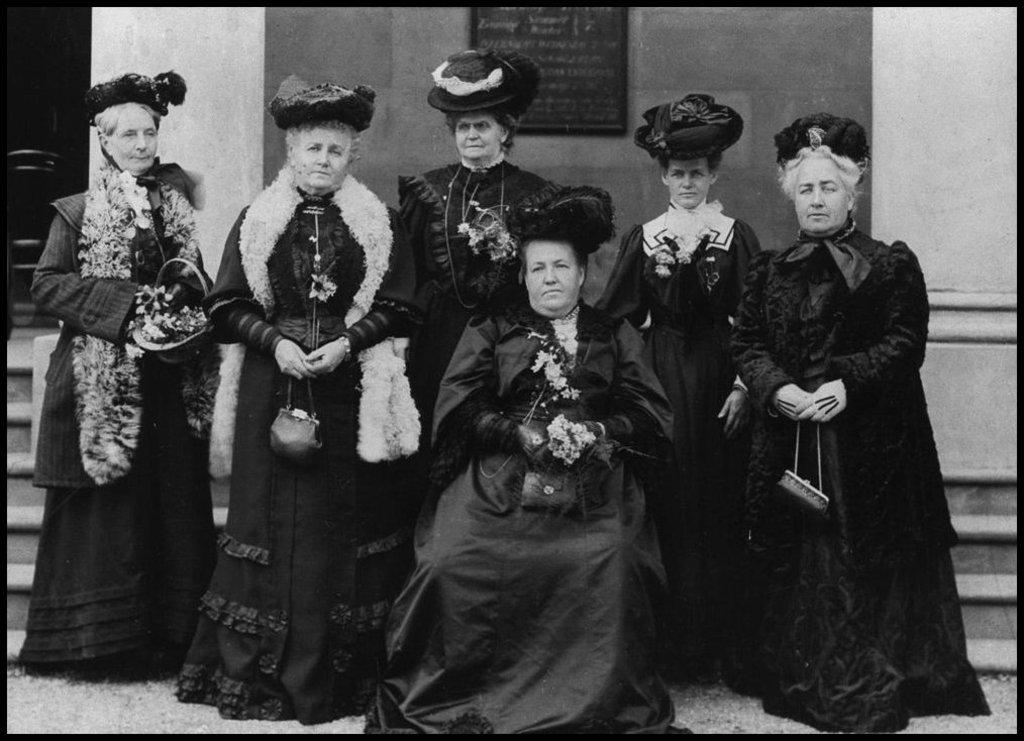What is the position of the woman in the image? There is a woman sitting in the image. How many other women are present in the image? There are five women standing in the image. What are the women in the image doing? All the women are looking at someone. Can you tell me the name of the boy the women are looking at in the image? There is no boy present in the image; all the women are looking at someone, but their gender is not specified. 